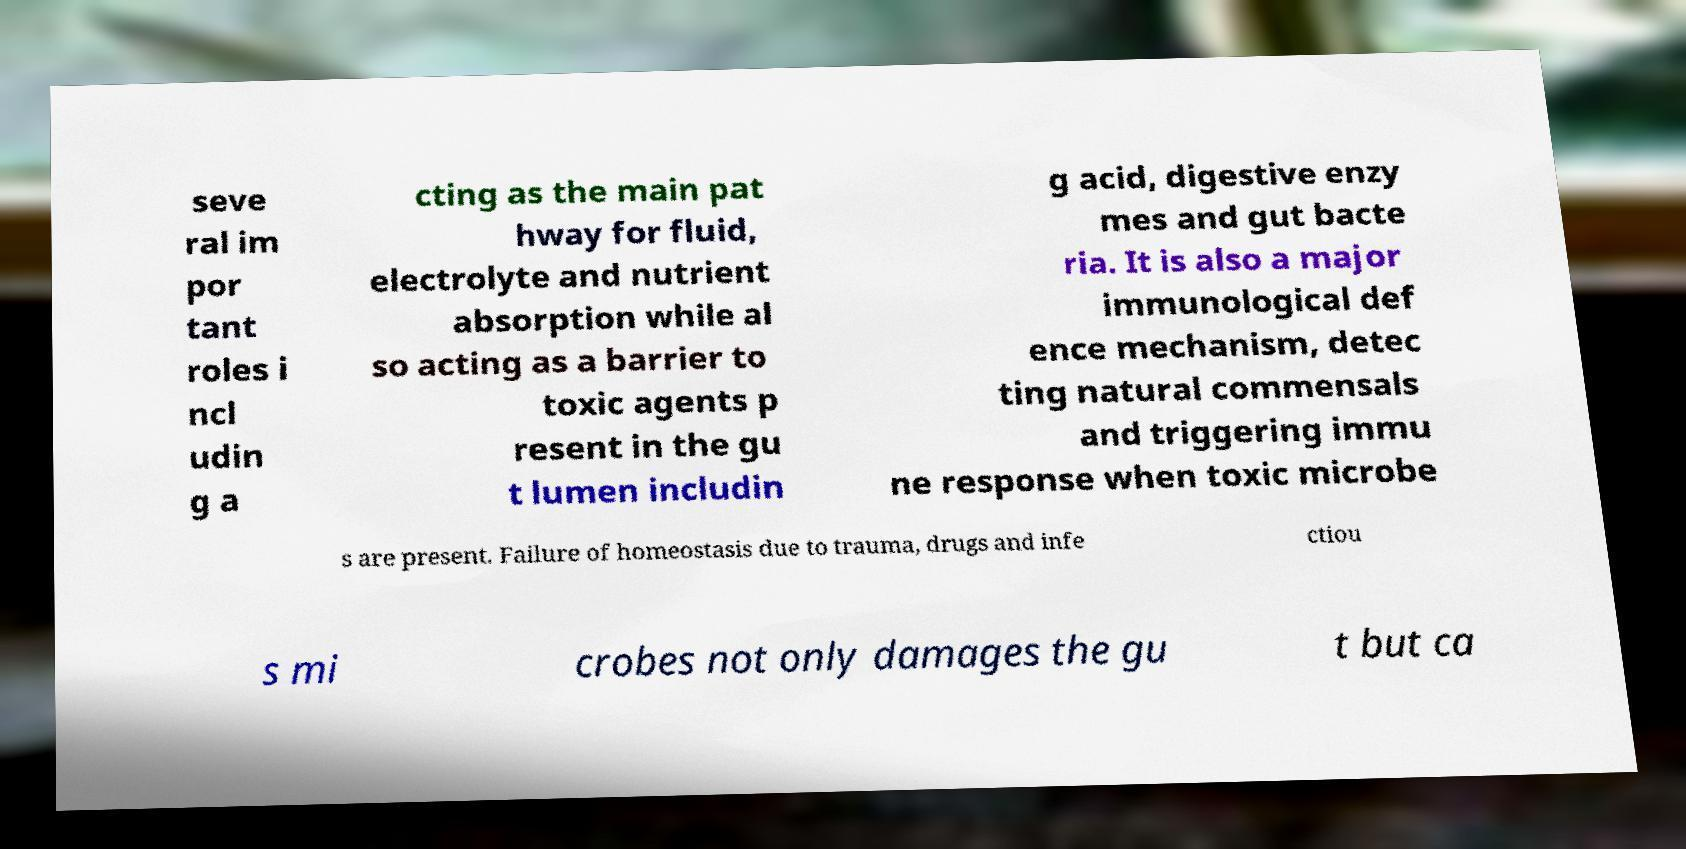What messages or text are displayed in this image? I need them in a readable, typed format. seve ral im por tant roles i ncl udin g a cting as the main pat hway for fluid, electrolyte and nutrient absorption while al so acting as a barrier to toxic agents p resent in the gu t lumen includin g acid, digestive enzy mes and gut bacte ria. It is also a major immunological def ence mechanism, detec ting natural commensals and triggering immu ne response when toxic microbe s are present. Failure of homeostasis due to trauma, drugs and infe ctiou s mi crobes not only damages the gu t but ca 